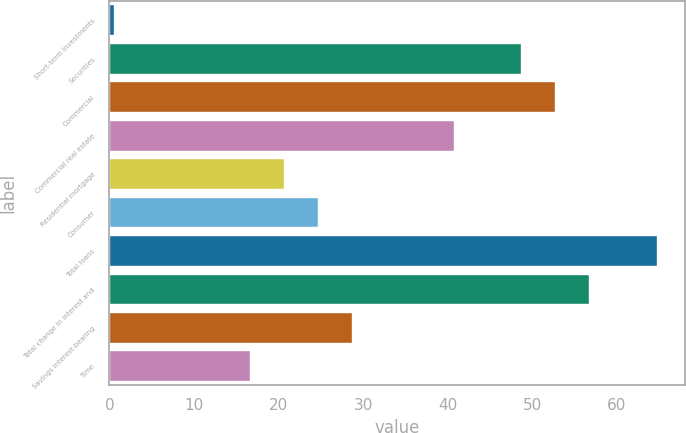Convert chart. <chart><loc_0><loc_0><loc_500><loc_500><bar_chart><fcel>Short-term investments<fcel>Securities<fcel>Commercial<fcel>Commercial real estate<fcel>Residential mortgage<fcel>Consumer<fcel>Total loans<fcel>Total change in interest and<fcel>Savings interest-bearing<fcel>Time<nl><fcel>0.5<fcel>48.74<fcel>52.76<fcel>40.7<fcel>20.6<fcel>24.62<fcel>64.82<fcel>56.78<fcel>28.64<fcel>16.58<nl></chart> 